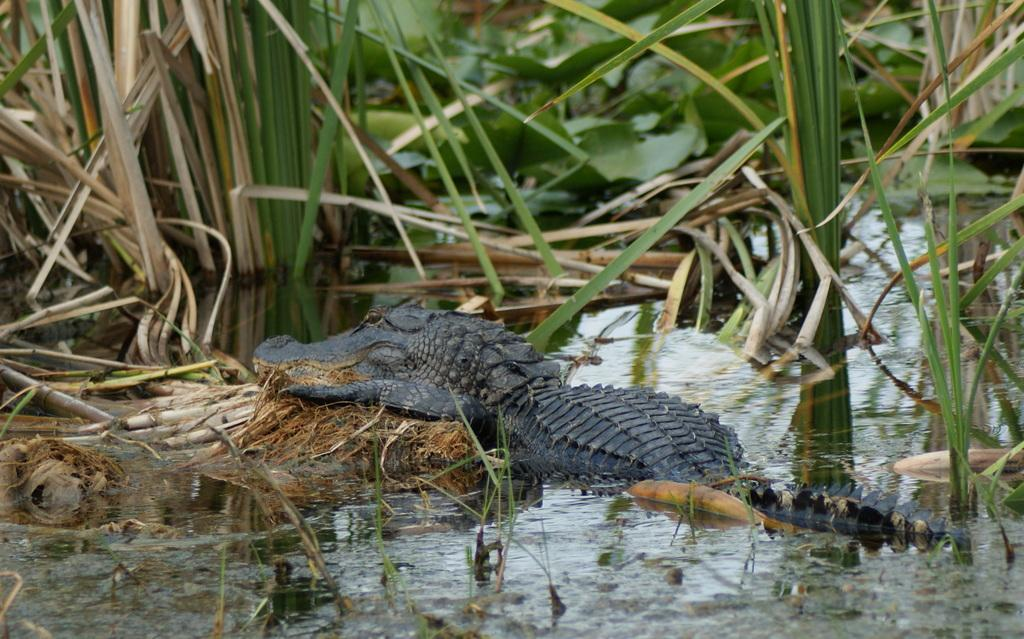What animal is the main subject of the picture? There is a crocodile in the picture. What can be seen in front of the crocodile? There are trees and water in front of the crocodile. How many ants can be seen crawling on the crocodile's back in the image? There are no ants visible on the crocodile's back in the image. What type of truck is parked next to the crocodile in the image? There is no truck present in the image; it features a crocodile, trees, and water. 